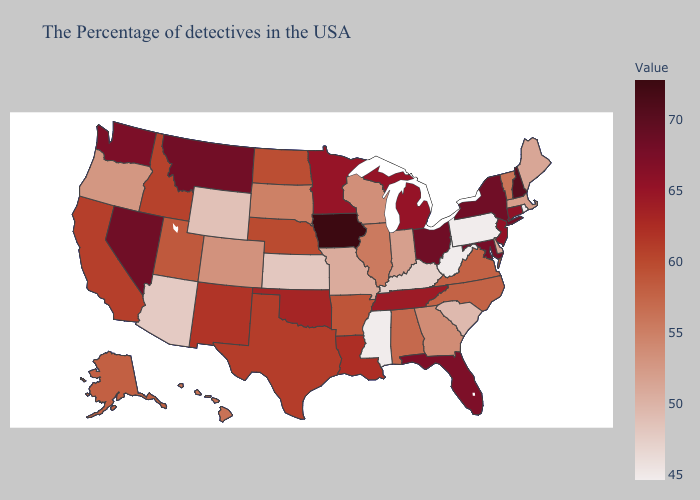Which states have the lowest value in the Northeast?
Short answer required. Rhode Island, Pennsylvania. Does Virginia have the lowest value in the South?
Give a very brief answer. No. Does Iowa have the highest value in the USA?
Give a very brief answer. Yes. Does Tennessee have the highest value in the USA?
Write a very short answer. No. Which states have the lowest value in the West?
Concise answer only. Arizona. Which states have the highest value in the USA?
Be succinct. Iowa. Which states hav the highest value in the South?
Be succinct. Maryland. Among the states that border New York , does Connecticut have the highest value?
Short answer required. Yes. 